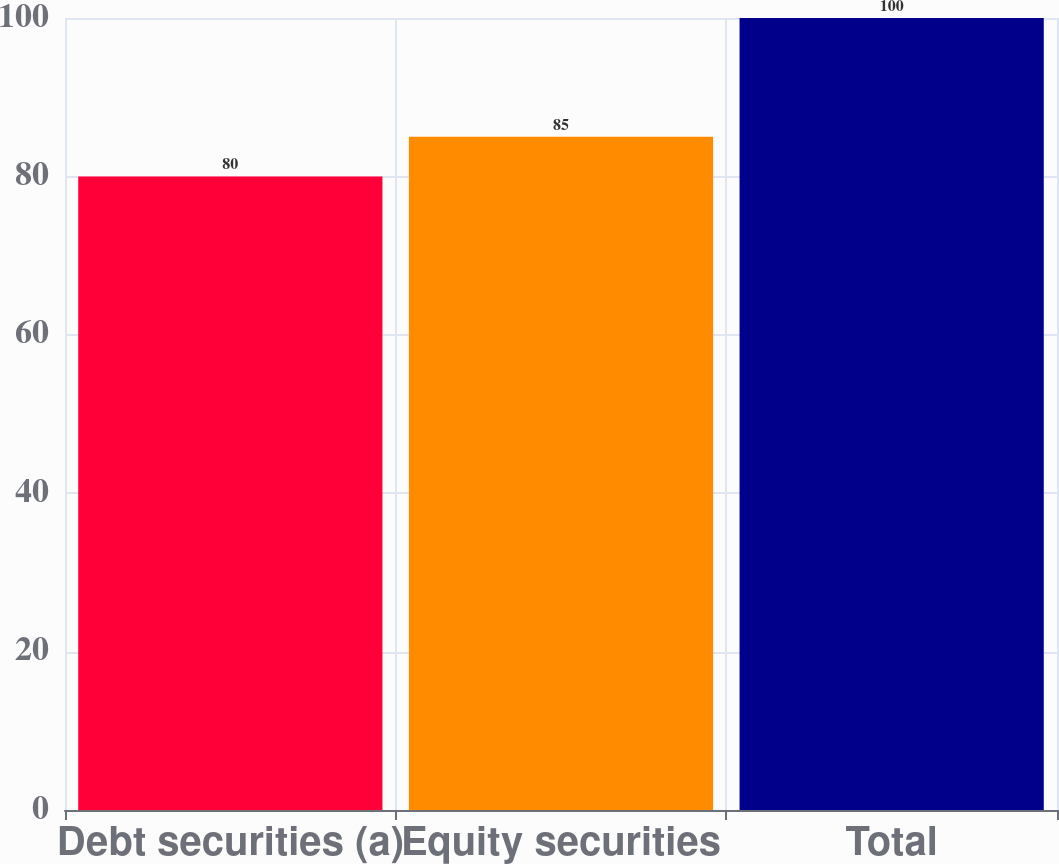Convert chart to OTSL. <chart><loc_0><loc_0><loc_500><loc_500><bar_chart><fcel>Debt securities (a)<fcel>Equity securities<fcel>Total<nl><fcel>80<fcel>85<fcel>100<nl></chart> 